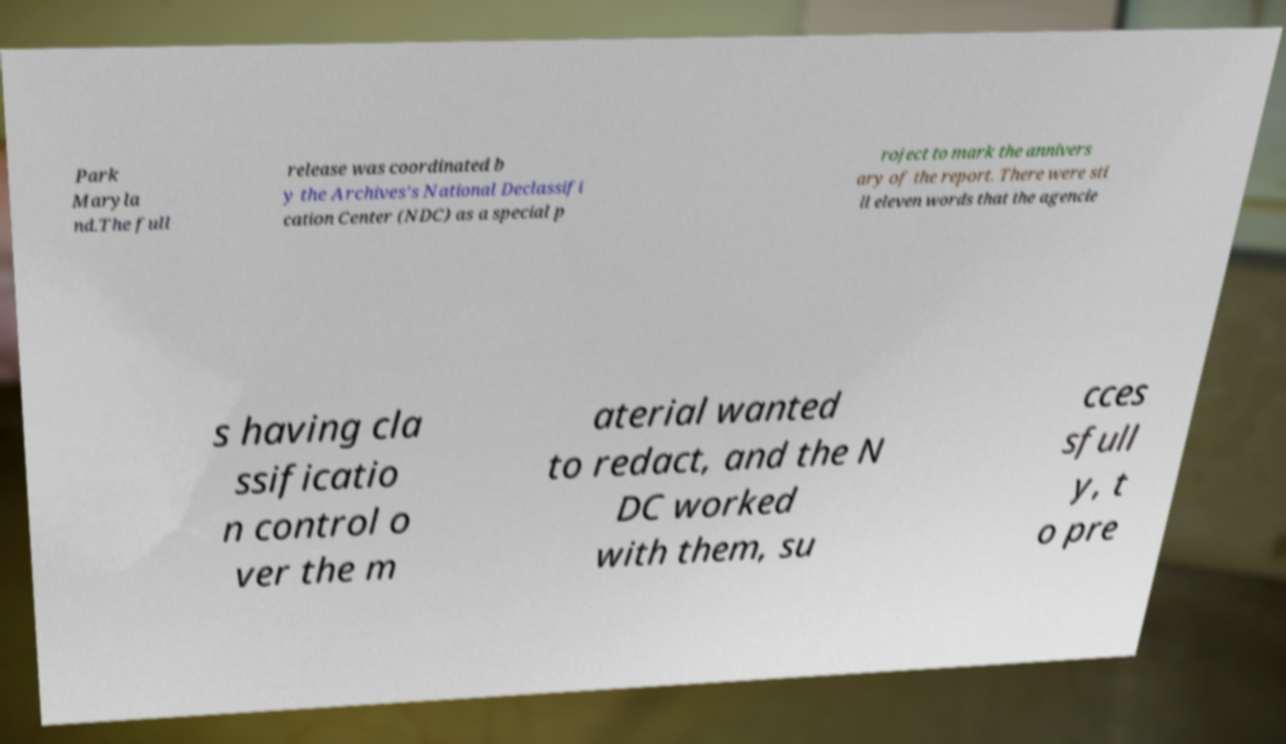I need the written content from this picture converted into text. Can you do that? Park Maryla nd.The full release was coordinated b y the Archives's National Declassifi cation Center (NDC) as a special p roject to mark the annivers ary of the report. There were sti ll eleven words that the agencie s having cla ssificatio n control o ver the m aterial wanted to redact, and the N DC worked with them, su cces sfull y, t o pre 